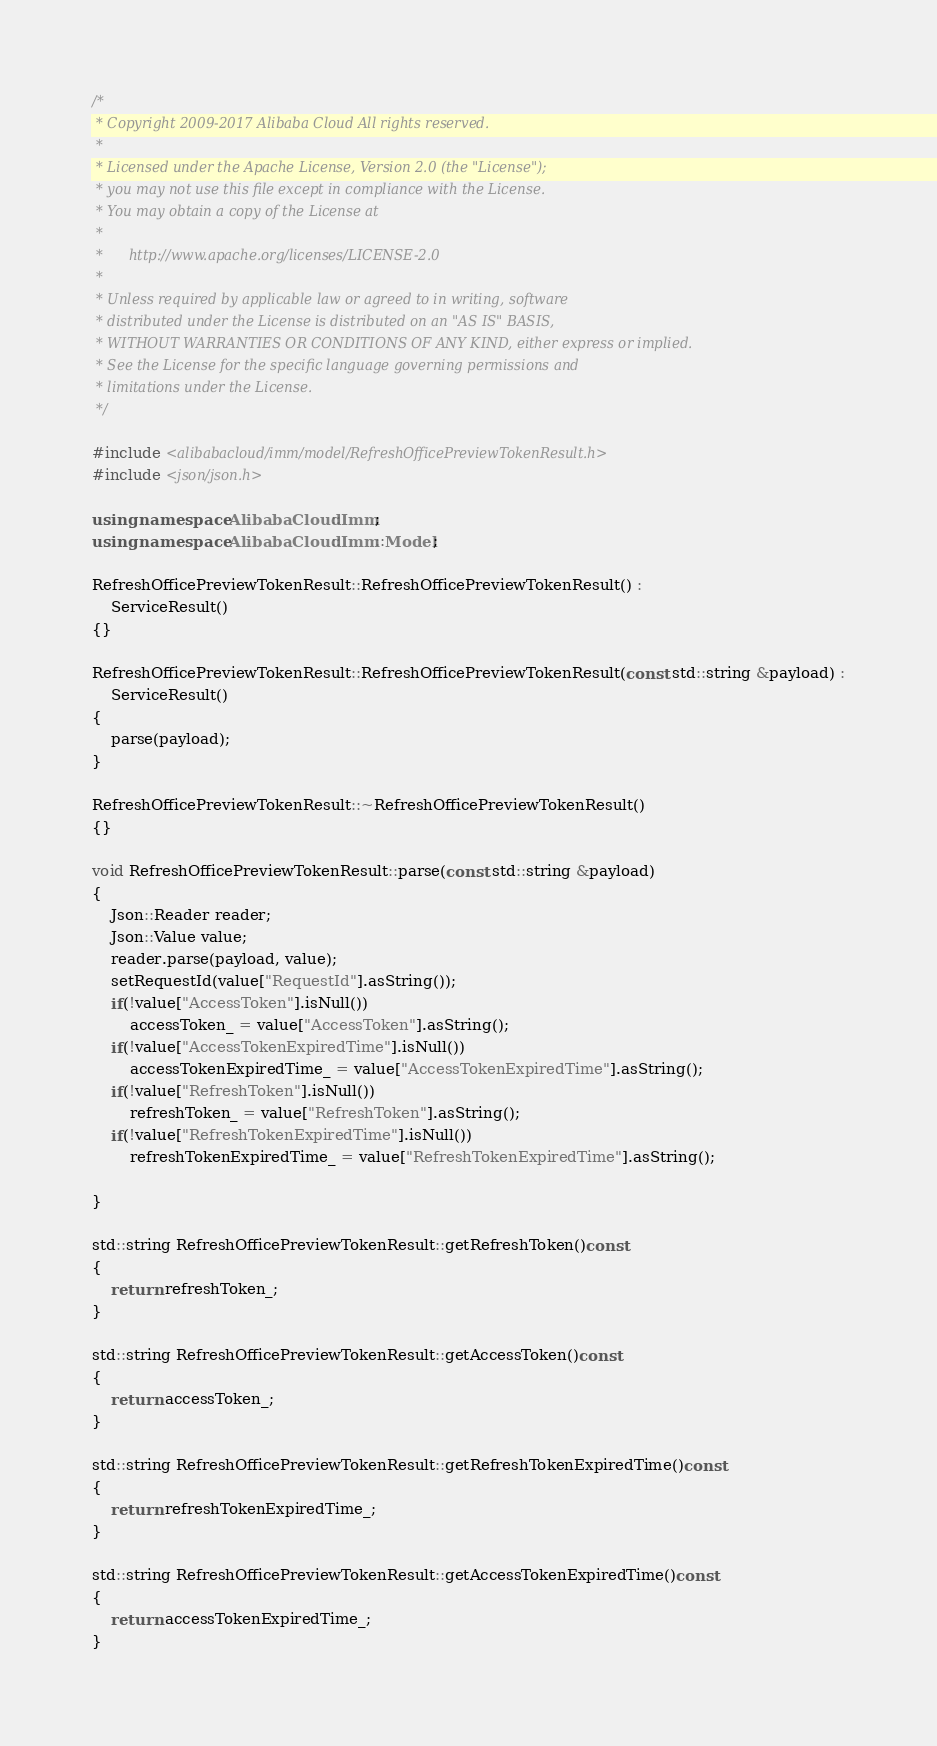Convert code to text. <code><loc_0><loc_0><loc_500><loc_500><_C++_>/*
 * Copyright 2009-2017 Alibaba Cloud All rights reserved.
 * 
 * Licensed under the Apache License, Version 2.0 (the "License");
 * you may not use this file except in compliance with the License.
 * You may obtain a copy of the License at
 * 
 *      http://www.apache.org/licenses/LICENSE-2.0
 * 
 * Unless required by applicable law or agreed to in writing, software
 * distributed under the License is distributed on an "AS IS" BASIS,
 * WITHOUT WARRANTIES OR CONDITIONS OF ANY KIND, either express or implied.
 * See the License for the specific language governing permissions and
 * limitations under the License.
 */

#include <alibabacloud/imm/model/RefreshOfficePreviewTokenResult.h>
#include <json/json.h>

using namespace AlibabaCloud::Imm;
using namespace AlibabaCloud::Imm::Model;

RefreshOfficePreviewTokenResult::RefreshOfficePreviewTokenResult() :
	ServiceResult()
{}

RefreshOfficePreviewTokenResult::RefreshOfficePreviewTokenResult(const std::string &payload) :
	ServiceResult()
{
	parse(payload);
}

RefreshOfficePreviewTokenResult::~RefreshOfficePreviewTokenResult()
{}

void RefreshOfficePreviewTokenResult::parse(const std::string &payload)
{
	Json::Reader reader;
	Json::Value value;
	reader.parse(payload, value);
	setRequestId(value["RequestId"].asString());
	if(!value["AccessToken"].isNull())
		accessToken_ = value["AccessToken"].asString();
	if(!value["AccessTokenExpiredTime"].isNull())
		accessTokenExpiredTime_ = value["AccessTokenExpiredTime"].asString();
	if(!value["RefreshToken"].isNull())
		refreshToken_ = value["RefreshToken"].asString();
	if(!value["RefreshTokenExpiredTime"].isNull())
		refreshTokenExpiredTime_ = value["RefreshTokenExpiredTime"].asString();

}

std::string RefreshOfficePreviewTokenResult::getRefreshToken()const
{
	return refreshToken_;
}

std::string RefreshOfficePreviewTokenResult::getAccessToken()const
{
	return accessToken_;
}

std::string RefreshOfficePreviewTokenResult::getRefreshTokenExpiredTime()const
{
	return refreshTokenExpiredTime_;
}

std::string RefreshOfficePreviewTokenResult::getAccessTokenExpiredTime()const
{
	return accessTokenExpiredTime_;
}

</code> 